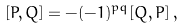<formula> <loc_0><loc_0><loc_500><loc_500>[ P , Q ] = - ( - 1 ) ^ { p q } [ Q , P ] \, ,</formula> 